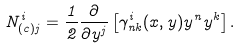<formula> <loc_0><loc_0><loc_500><loc_500>N _ { ( c ) j } ^ { i } = \frac { 1 } { 2 } \frac { \partial } { \partial y ^ { j } } \left [ \gamma _ { n k } ^ { i } ( x , y ) y ^ { n } y ^ { k } \right ] .</formula> 